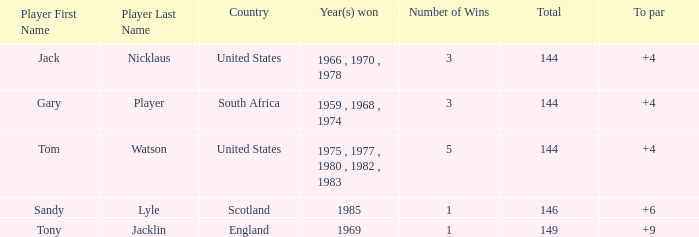When the sum was more than 144, what was the smallest to par score recorded by tom watson? None. 